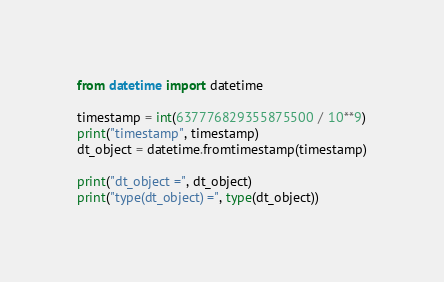<code> <loc_0><loc_0><loc_500><loc_500><_Python_>from datetime import datetime

timestamp = int(637776829355875500 / 10**9)
print("timestamp", timestamp)
dt_object = datetime.fromtimestamp(timestamp)

print("dt_object =", dt_object)
print("type(dt_object) =", type(dt_object))
</code> 